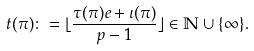<formula> <loc_0><loc_0><loc_500><loc_500>t ( \pi ) \colon = \lfloor \frac { \tau ( \pi ) e + \iota ( \pi ) } { p - 1 } \rfloor \in \mathbb { N } \cup \{ \infty \} .</formula> 